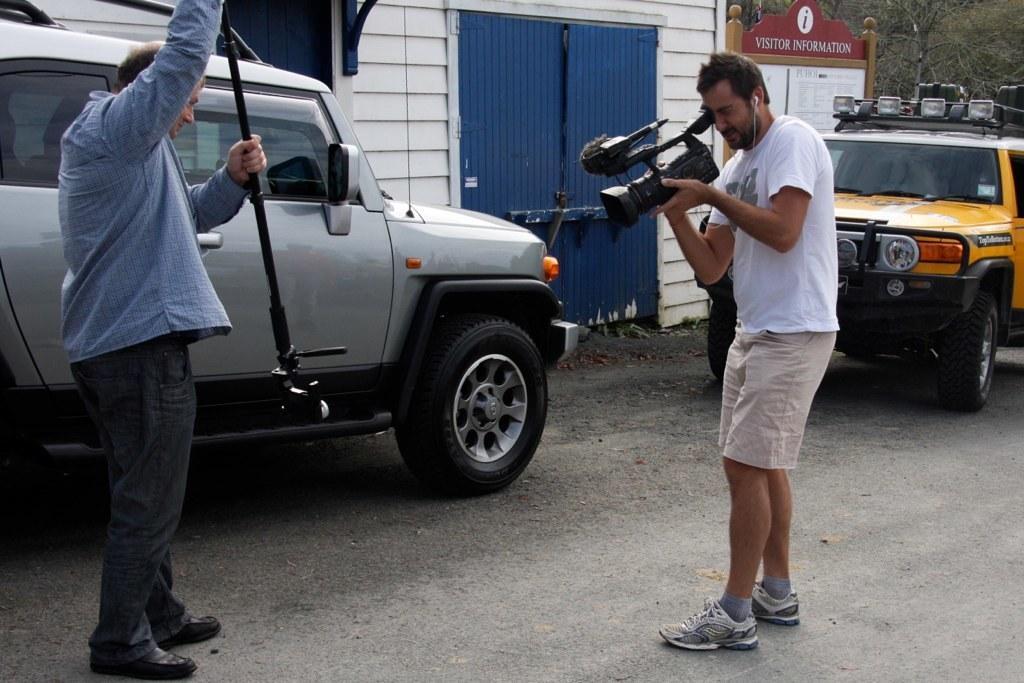Describe this image in one or two sentences. In this image I can see a person wearing blue and black colored dress is standing and holding a black colored object in his hand. I can see another person wearing white colored dress is standing and holding a camera in his hand. In the background I can see few vehicles on the ground, a building which is white in color, blue colored gate , the brown and red colored board to which I can see few papers attached and few trees. 